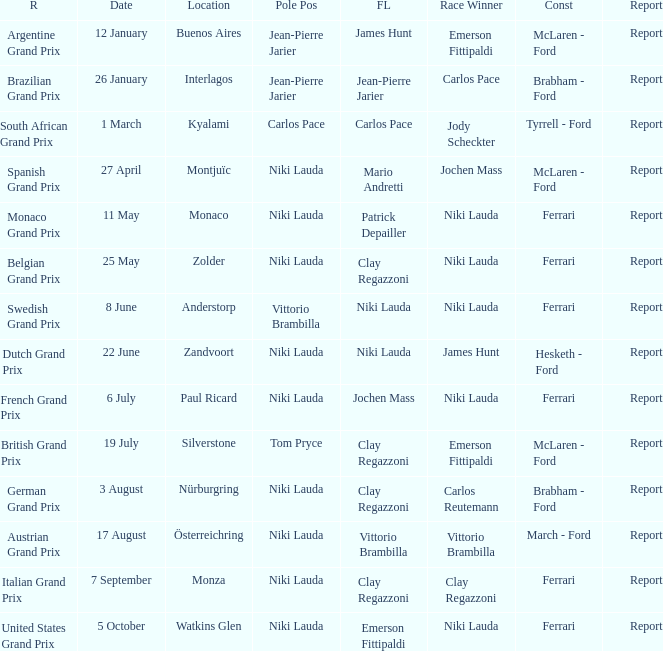Where did the team in which Tom Pryce was in Pole Position race? Silverstone. 